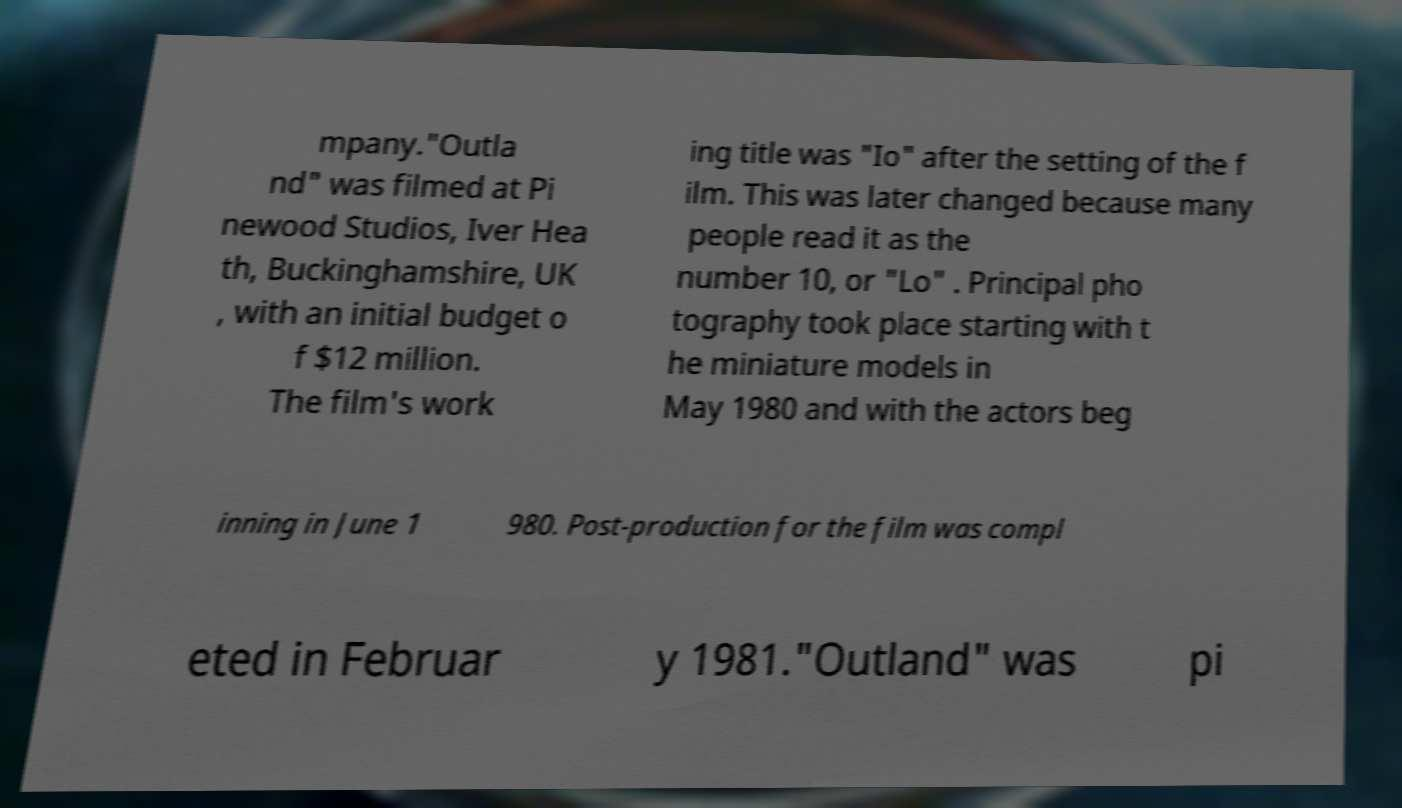Can you accurately transcribe the text from the provided image for me? mpany."Outla nd" was filmed at Pi newood Studios, Iver Hea th, Buckinghamshire, UK , with an initial budget o f $12 million. The film's work ing title was "Io" after the setting of the f ilm. This was later changed because many people read it as the number 10, or "Lo" . Principal pho tography took place starting with t he miniature models in May 1980 and with the actors beg inning in June 1 980. Post-production for the film was compl eted in Februar y 1981."Outland" was pi 